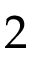<formula> <loc_0><loc_0><loc_500><loc_500>2</formula> 